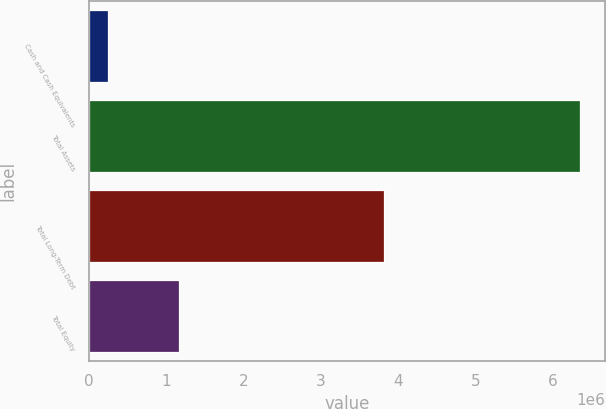Convert chart. <chart><loc_0><loc_0><loc_500><loc_500><bar_chart><fcel>Cash and Cash Equivalents<fcel>Total Assets<fcel>Total Long-Term Debt<fcel>Total Equity<nl><fcel>243415<fcel>6.35834e+06<fcel>3.825e+06<fcel>1.16245e+06<nl></chart> 